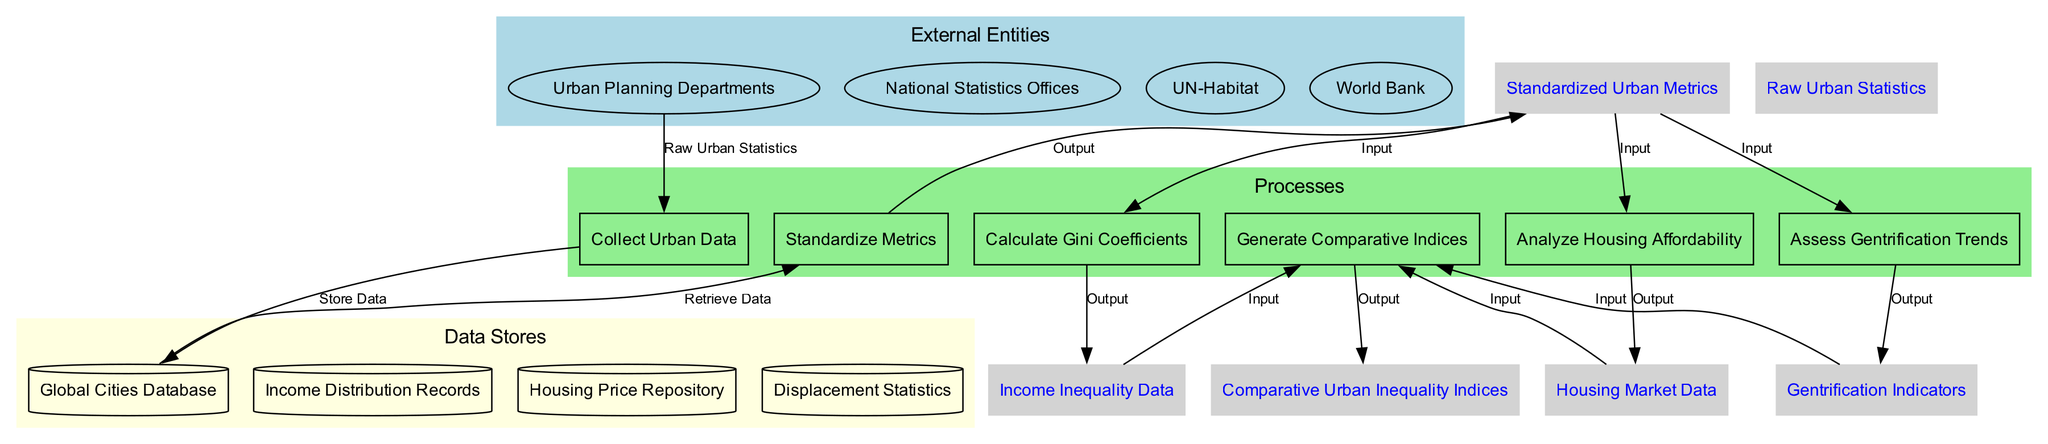What is the number of external entities in the diagram? The diagram indicates four external entities: Urban Planning Departments, National Statistics Offices, UN-Habitat, and World Bank. This can be counted directly from the "External Entities" section of the diagram.
Answer: 4 Which process receives raw urban statistics? The process that receives raw urban statistics is "Collect Urban Data." This is linked in the diagram by an arrow from the external entity.
Answer: Collect Urban Data How many processes are listed in the diagram? The diagram features six processes: Collect Urban Data, Standardize Metrics, Calculate Gini Coefficients, Analyze Housing Affordability, Assess Gentrification Trends, and Generate Comparative Indices. This can be counted directly in the "Processes" section.
Answer: 6 What type of data is generated by the process "Generate Comparative Indices"? The output of the "Generate Comparative Indices" process is the "Comparative Urban Inequality Indices." This is the final output shown in the diagram that concludes the data flow.
Answer: Comparative Urban Inequality Indices Which data store is used to assess gentrification trends? The process "Assess Gentrification Trends" receives inputs from the "Gentrification Indicators," which are derived from earlier data flows, but there is no specific data store directly linked to it in the diagram. Therefore, it references a collected flow rather than a store.
Answer: N/A How many types of data flows are shown in the diagram? The diagram outlines five different data flows: Raw Urban Statistics, Standardized Urban Metrics, Income Inequality Data, Housing Market Data, and Gentrification Indicators. A count of these items will reveal the total number of data flows present.
Answer: 5 Which data store holds income distribution records? The data store that contains income distribution records is labeled as "Income Distribution Records." This is explicitly stated in the "Data Stores" section of the diagram.
Answer: Income Distribution Records What is the connection between "Calculate Gini Coefficients" and "Generate Comparative Indices"? The "Calculate Gini Coefficients" process outputs "Income Inequality Data," which is then inputted into the "Generate Comparative Indices" process, creating a direct data flow as represented by the arrows in the diagram.
Answer: Income Inequality Data Which external entity is associated with housing data? The external entity linked with housing data in the process flow is UN-Habitat, which likely provides relevant housing statistics to the data processing system as per the diagram's structure.
Answer: UN-Habitat 